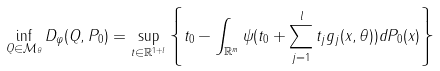<formula> <loc_0><loc_0><loc_500><loc_500>\inf _ { Q \in \mathcal { M } _ { \theta } } D _ { \varphi } ( Q , P _ { 0 } ) = \sup _ { t \in \mathbb { R } ^ { 1 + l } } \left \{ t _ { 0 } - \int _ { \mathbb { R } ^ { m } } \psi ( t _ { 0 } + \sum _ { j = 1 } ^ { l } t _ { j } g _ { j } ( x , \theta ) ) d P _ { 0 } ( x ) \right \}</formula> 